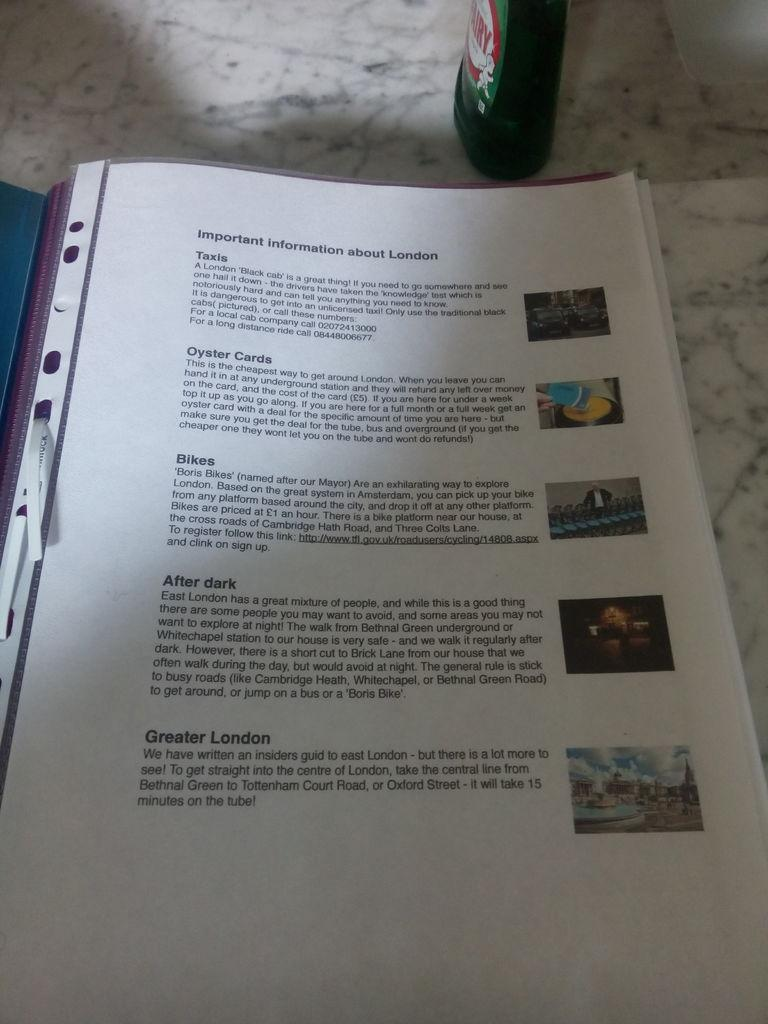<image>
Give a short and clear explanation of the subsequent image. A printed page with important information about London has pictures on it too. 